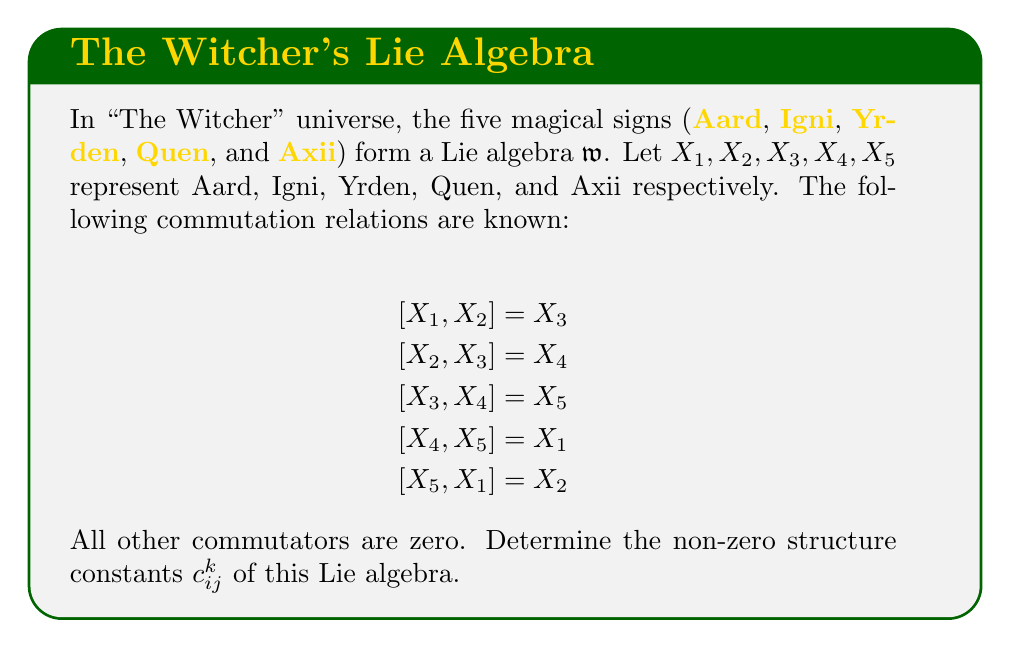Give your solution to this math problem. To find the structure constants, we need to express each commutator in terms of the basis elements:

$$[X_i, X_j] = \sum_{k=1}^5 c_{ij}^k X_k$$

where $c_{ij}^k$ are the structure constants.

From the given commutation relations:

1) $[X_1, X_2] = X_3$ implies $c_{12}^3 = 1$
2) $[X_2, X_3] = X_4$ implies $c_{23}^4 = 1$
3) $[X_3, X_4] = X_5$ implies $c_{34}^5 = 1$
4) $[X_4, X_5] = X_1$ implies $c_{45}^1 = 1$
5) $[X_5, X_1] = X_2$ implies $c_{51}^2 = 1$

Note that $c_{ij}^k = -c_{ji}^k$ due to the antisymmetry of the Lie bracket. Therefore:

6) $c_{21}^3 = -1$
7) $c_{32}^4 = -1$
8) $c_{43}^5 = -1$
9) $c_{54}^1 = -1$
10) $c_{15}^2 = -1$

All other structure constants are zero.
Answer: $c_{12}^3 = c_{23}^4 = c_{34}^5 = c_{45}^1 = c_{51}^2 = 1$, $c_{21}^3 = c_{32}^4 = c_{43}^5 = c_{54}^1 = c_{15}^2 = -1$, others $= 0$ 